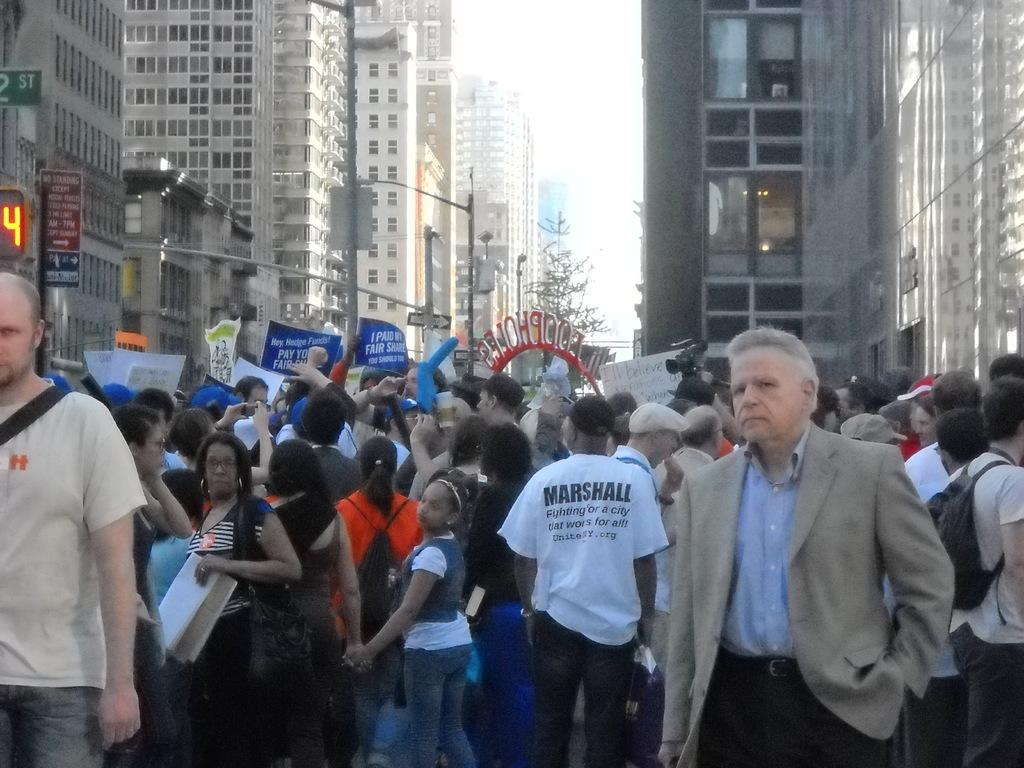What is happening in the image involving a group of people? There is a group of people in the image, and they are holding banners. What color are the banners being held by the people? The banners are blue. What can be seen in the background of the image? There are buildings, trees, and the sky visible in the background of the image. What type of cake is being served to the porter in the image? There is no cake or porter present in the image. 